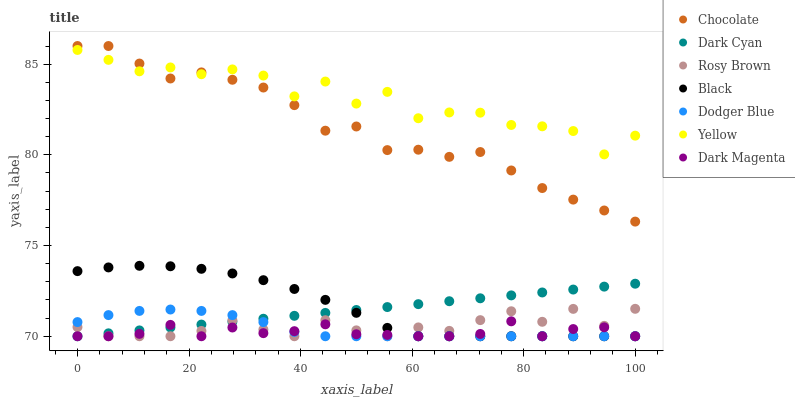Does Dark Magenta have the minimum area under the curve?
Answer yes or no. Yes. Does Yellow have the maximum area under the curve?
Answer yes or no. Yes. Does Rosy Brown have the minimum area under the curve?
Answer yes or no. No. Does Rosy Brown have the maximum area under the curve?
Answer yes or no. No. Is Dark Cyan the smoothest?
Answer yes or no. Yes. Is Yellow the roughest?
Answer yes or no. Yes. Is Rosy Brown the smoothest?
Answer yes or no. No. Is Rosy Brown the roughest?
Answer yes or no. No. Does Dark Magenta have the lowest value?
Answer yes or no. Yes. Does Yellow have the lowest value?
Answer yes or no. No. Does Chocolate have the highest value?
Answer yes or no. Yes. Does Rosy Brown have the highest value?
Answer yes or no. No. Is Dark Cyan less than Yellow?
Answer yes or no. Yes. Is Yellow greater than Black?
Answer yes or no. Yes. Does Rosy Brown intersect Dark Magenta?
Answer yes or no. Yes. Is Rosy Brown less than Dark Magenta?
Answer yes or no. No. Is Rosy Brown greater than Dark Magenta?
Answer yes or no. No. Does Dark Cyan intersect Yellow?
Answer yes or no. No. 